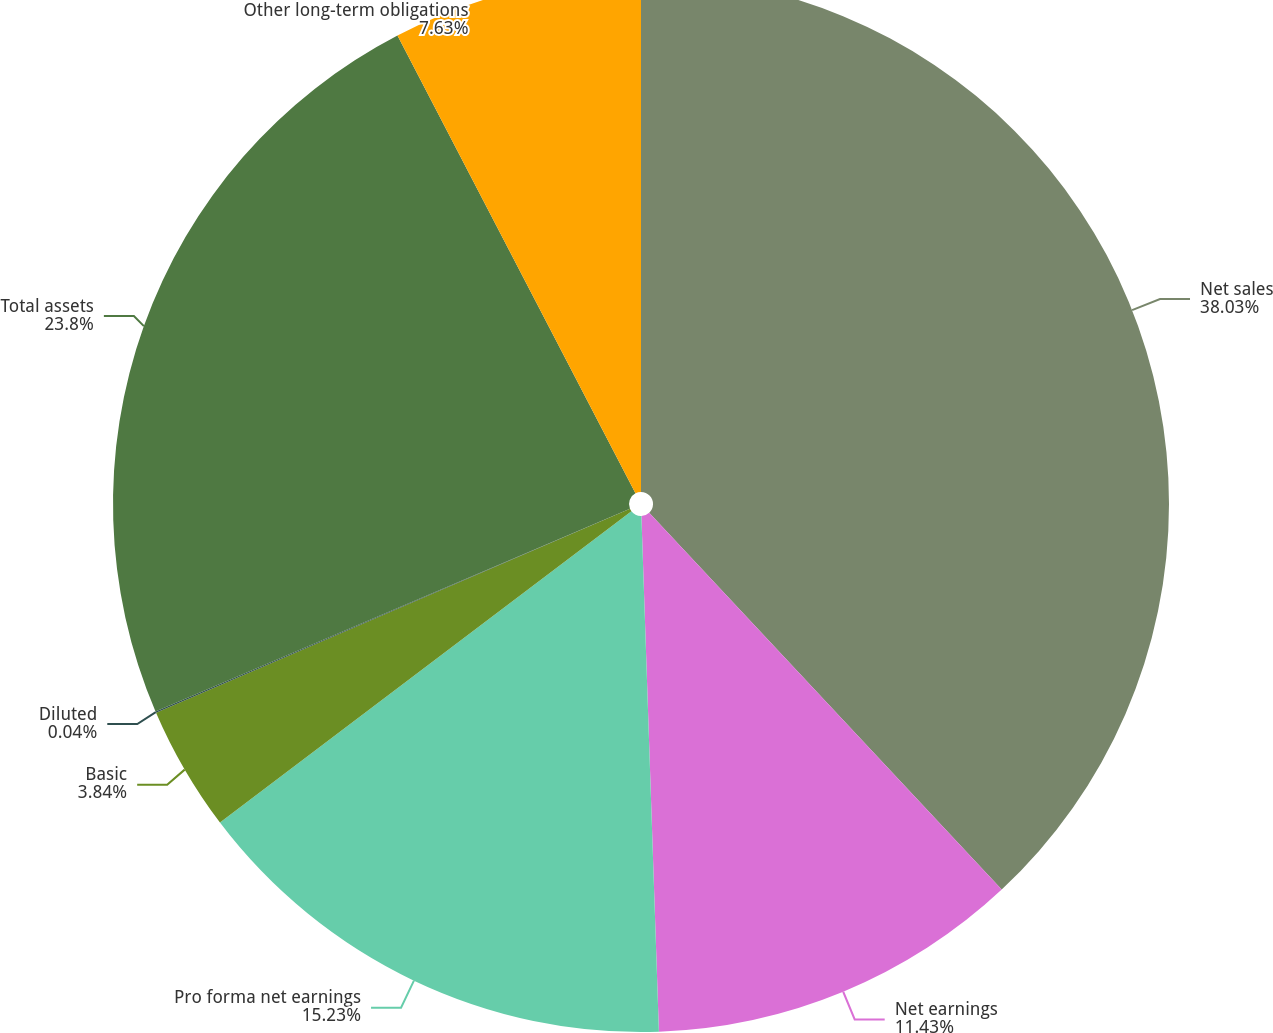Convert chart. <chart><loc_0><loc_0><loc_500><loc_500><pie_chart><fcel>Net sales<fcel>Net earnings<fcel>Pro forma net earnings<fcel>Basic<fcel>Diluted<fcel>Total assets<fcel>Other long-term obligations<nl><fcel>38.03%<fcel>11.43%<fcel>15.23%<fcel>3.84%<fcel>0.04%<fcel>23.8%<fcel>7.63%<nl></chart> 